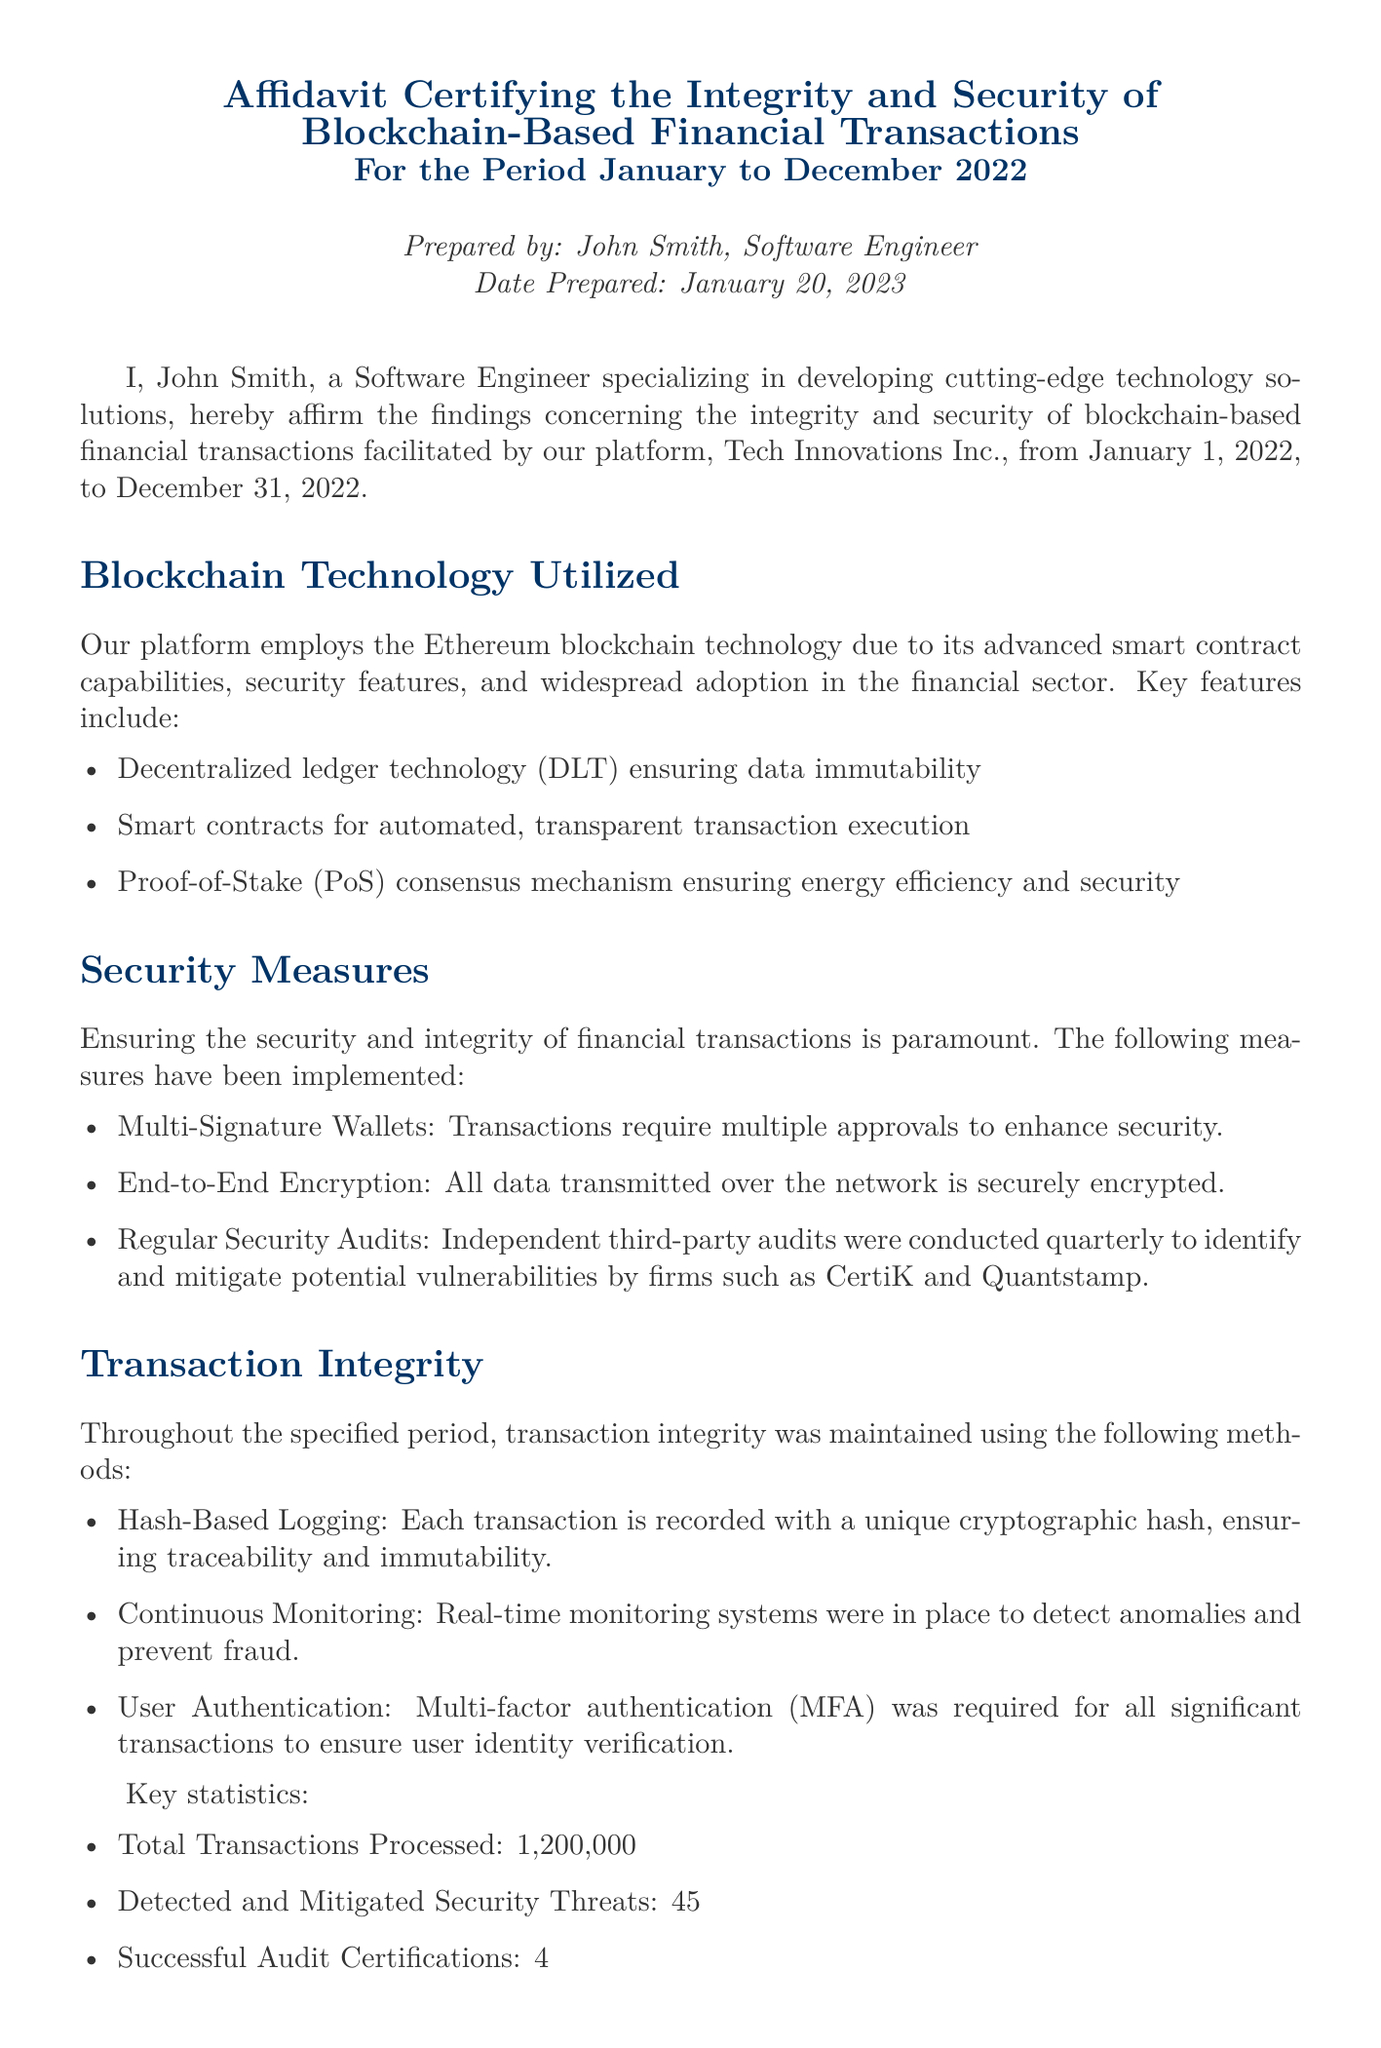What is the name of the software engineer who prepared the affidavit? The affidavit states that it was prepared by John Smith, who is a software engineer.
Answer: John Smith What period does the affidavit cover? The affidavit certifies the integrity and security of transactions for the period from January 1, 2022, to December 31, 2022.
Answer: January to December 2022 How many total transactions were processed according to the affidavit? The document mentions that a total of 1,200,000 transactions were processed within the specified period.
Answer: 1,200,000 Who performed the independent security audits? The affidavit lists firms such as CertiK and Quantstamp as the independent auditors that conducted quarterly security audits.
Answer: CertiK and Quantstamp What security measure requires multiple approvals for transactions? The document outlines that multi-signature wallets are utilized to require multiple approvals to enhance transaction security.
Answer: Multi-Signature Wallets What mechanism does the blockchain utilize for consensus? The affidavit states that the platform employs a Proof-of-Stake consensus mechanism to ensure energy efficiency and security.
Answer: Proof-of-Stake How many security threats were detected and mitigated? According to the document, there were 45 detected and mitigated security threats during the reported period.
Answer: 45 What is the purpose of multi-factor authentication mentioned in the affidavit? The affidavit indicates that multi-factor authentication is required for all significant transactions to ensure user identity verification.
Answer: User identity verification Who is requested to review and sign the affidavit? The document requests Jane Doe, the Risk Manager, to review and sign the affidavit for official certification.
Answer: Jane Doe 